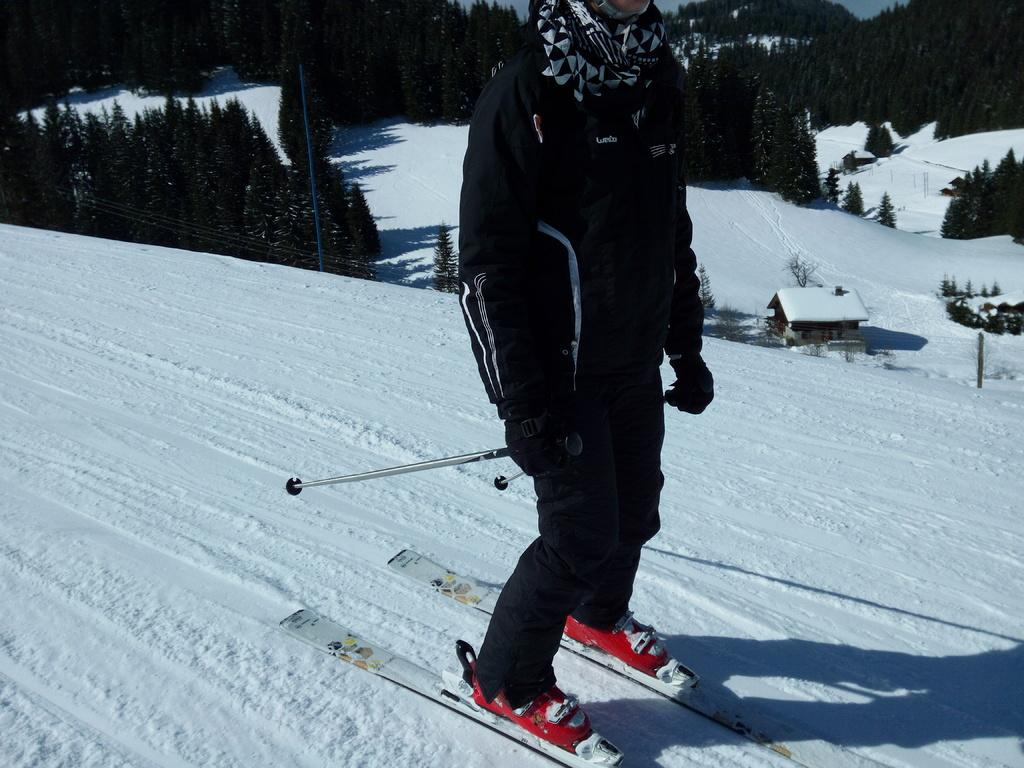What activity is the person in the image engaged in? The person is skiing in the image. What equipment is the person using for skiing? The person is using ski boards and holding sticks in their hands. What is the surface on which the person is skiing? The skiing is taking place on snow. Can you describe any structures in the image? There is a house in the image. What type of natural environment is visible in the image? There are trees in the image, and the sky is visible. What type of garden can be seen in the image? There is no garden present in the image; it features a person skiing on snow with a house and trees in the background. 